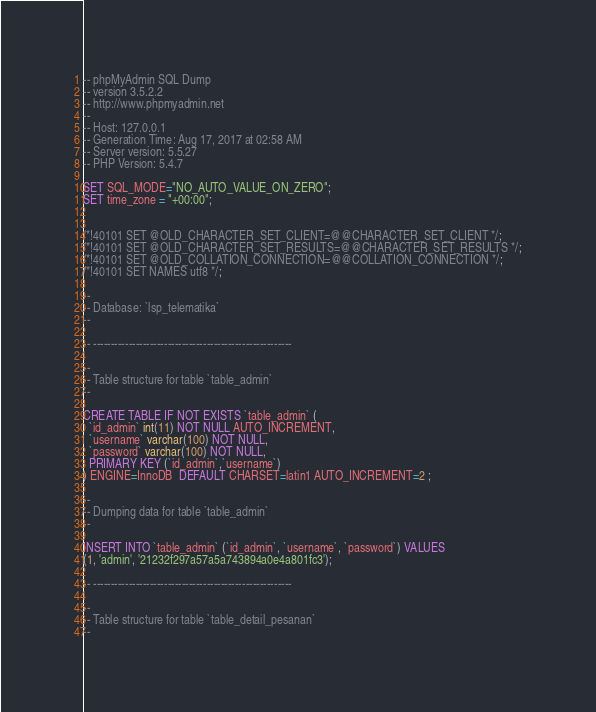<code> <loc_0><loc_0><loc_500><loc_500><_SQL_>-- phpMyAdmin SQL Dump
-- version 3.5.2.2
-- http://www.phpmyadmin.net
--
-- Host: 127.0.0.1
-- Generation Time: Aug 17, 2017 at 02:58 AM
-- Server version: 5.5.27
-- PHP Version: 5.4.7

SET SQL_MODE="NO_AUTO_VALUE_ON_ZERO";
SET time_zone = "+00:00";


/*!40101 SET @OLD_CHARACTER_SET_CLIENT=@@CHARACTER_SET_CLIENT */;
/*!40101 SET @OLD_CHARACTER_SET_RESULTS=@@CHARACTER_SET_RESULTS */;
/*!40101 SET @OLD_COLLATION_CONNECTION=@@COLLATION_CONNECTION */;
/*!40101 SET NAMES utf8 */;

--
-- Database: `lsp_telematika`
--

-- --------------------------------------------------------

--
-- Table structure for table `table_admin`
--

CREATE TABLE IF NOT EXISTS `table_admin` (
  `id_admin` int(11) NOT NULL AUTO_INCREMENT,
  `username` varchar(100) NOT NULL,
  `password` varchar(100) NOT NULL,
  PRIMARY KEY (`id_admin`,`username`)
) ENGINE=InnoDB  DEFAULT CHARSET=latin1 AUTO_INCREMENT=2 ;

--
-- Dumping data for table `table_admin`
--

INSERT INTO `table_admin` (`id_admin`, `username`, `password`) VALUES
(1, 'admin', '21232f297a57a5a743894a0e4a801fc3');

-- --------------------------------------------------------

--
-- Table structure for table `table_detail_pesanan`
--
</code> 